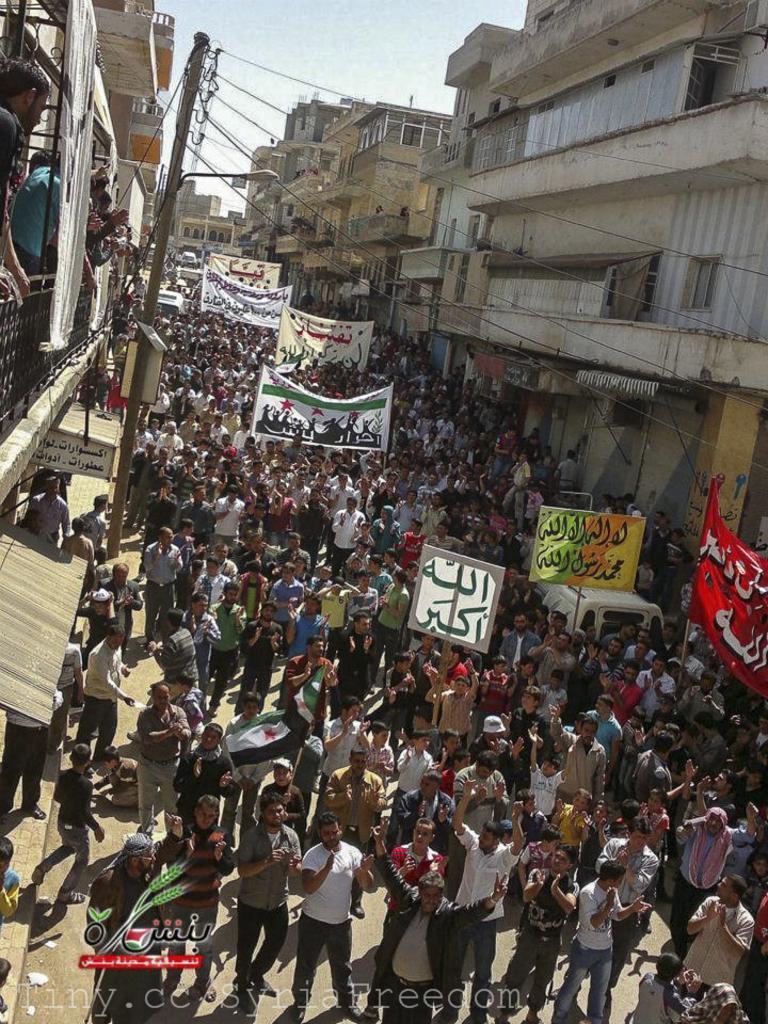In one or two sentences, can you explain what this image depicts? In the image there are many people on the road. And there are few people holding banners and boards in their hands. And also there is an electrical pole with wires and street light. And also there are many buildings with walls, roofs and also there are railings. At the top of the image there is sky. 